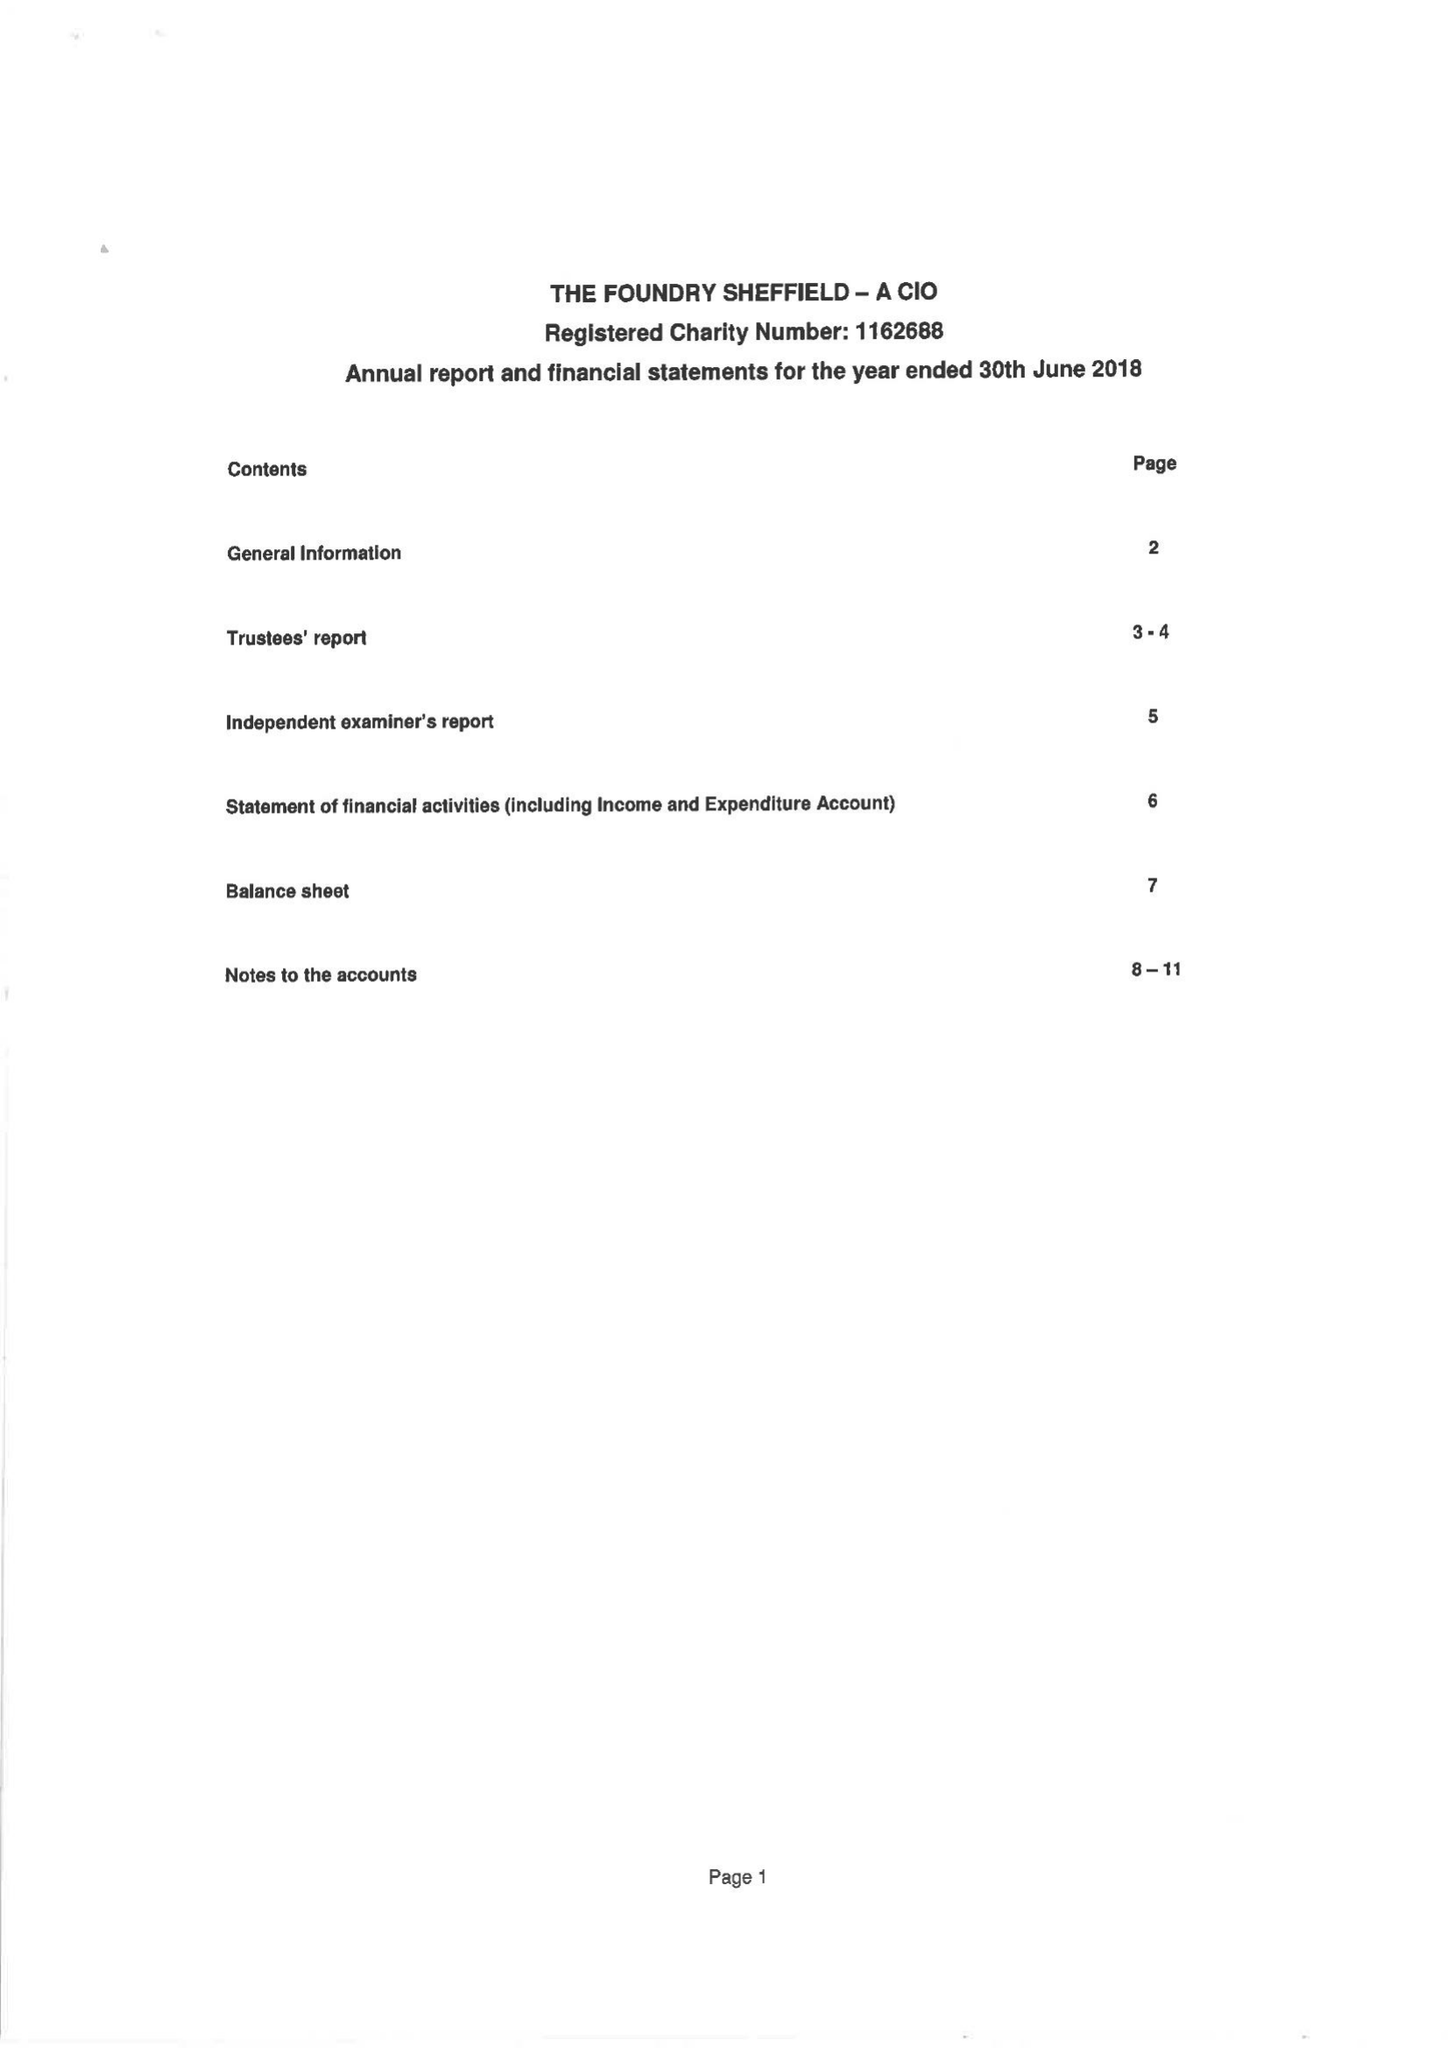What is the value for the spending_annually_in_british_pounds?
Answer the question using a single word or phrase. 196039.00 